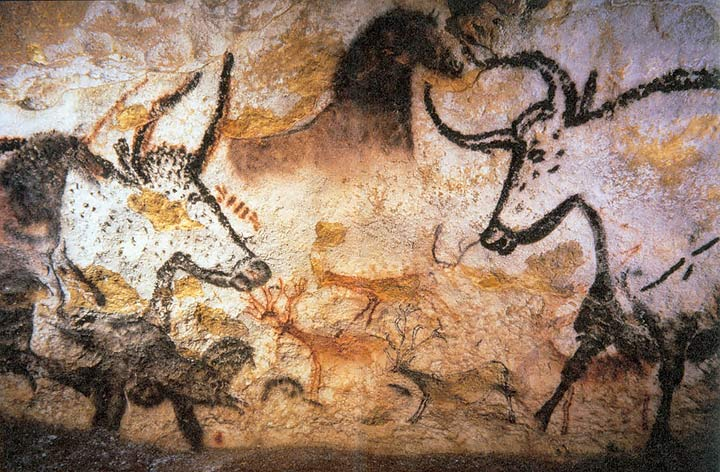Can you tell the significance of these animals in prehistoric societies? Certainly, the animals depicted in the Lascaux Caves, like horses, bulls, and deer, held significant symbolic meanings in prehistoric societies. These animals were integral to the survival and spirituality of these communities. They are often interpreted as symbols of fertility, power, and the abundance of nature. Their repeated, lively representations could also signify their roles in myths or as spirit guides in rituals. 